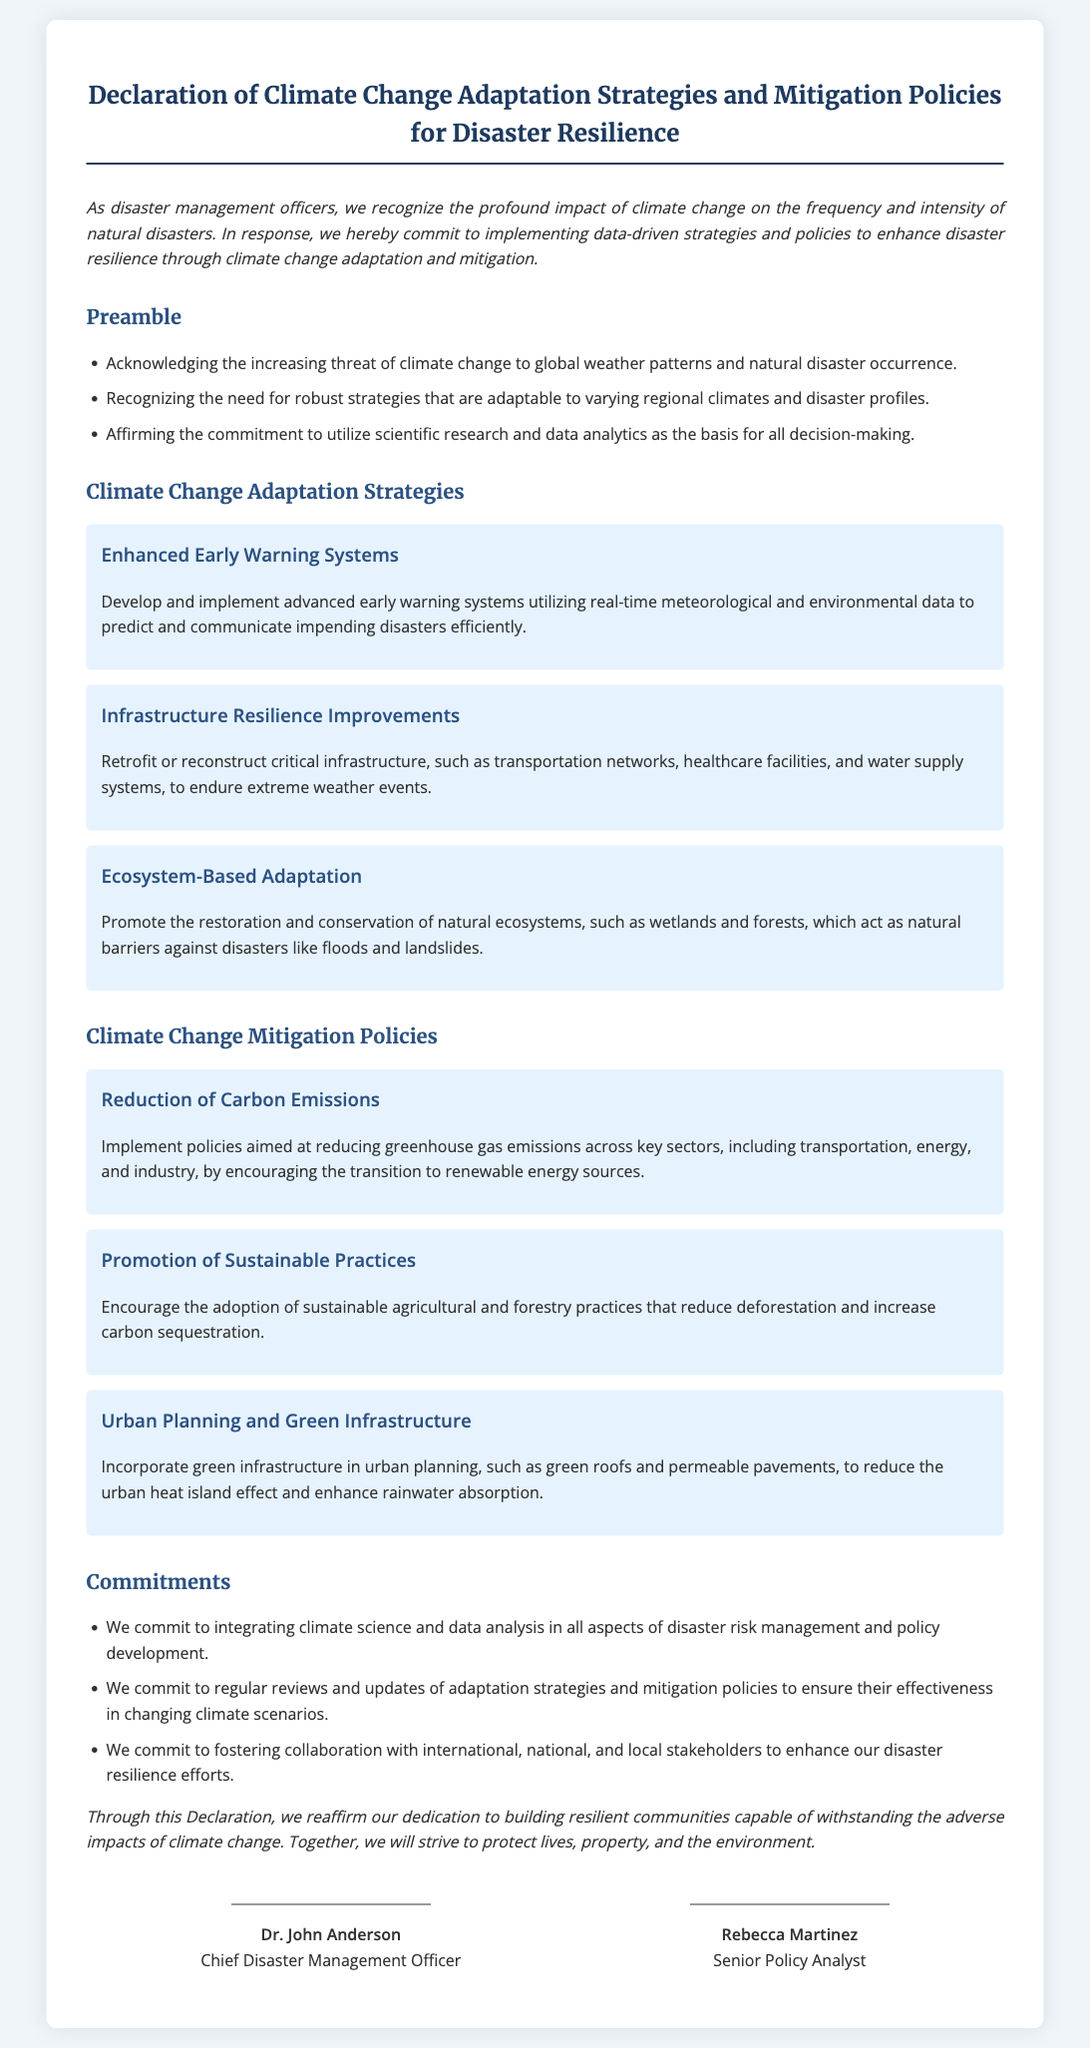What is the title of the document? The title of the document is prominently displayed at the top and states the purpose of the declaration.
Answer: Declaration of Climate Change Adaptation Strategies and Mitigation Policies for Disaster Resilience Who is the Chief Disaster Management Officer? The document lists the signatories, one of whom holds the title of Chief Disaster Management Officer.
Answer: Dr. John Anderson What strategy focuses on improving critical infrastructure? The strategies section of the document details various adaptation strategies, specifically mentioning improvements for infrastructure.
Answer: Infrastructure Resilience Improvements How many commitments are listed in the document? The commitments section outlines specific commitments made by the officers and can be quantified by counting the listed items.
Answer: Three What is one natural ecosystem mentioned as a barrier against disasters? The Ecosystem-Based Adaptation strategy specifically cites a type of ecosystem used for disaster protection.
Answer: Wetlands Which policy encourages the use of renewable energy sources? The document describes policies aimed at reducing greenhouse gas emissions, which includes transitioning to renewable energy.
Answer: Reduction of Carbon Emissions What is the font used for the document's headings? The style attributes in the document specify which font families are utilized for headings.
Answer: Merriweather What is the main goal of this declaration? The conclusion summarizes the overall objective and intent behind the declaration.
Answer: Building resilient communities 